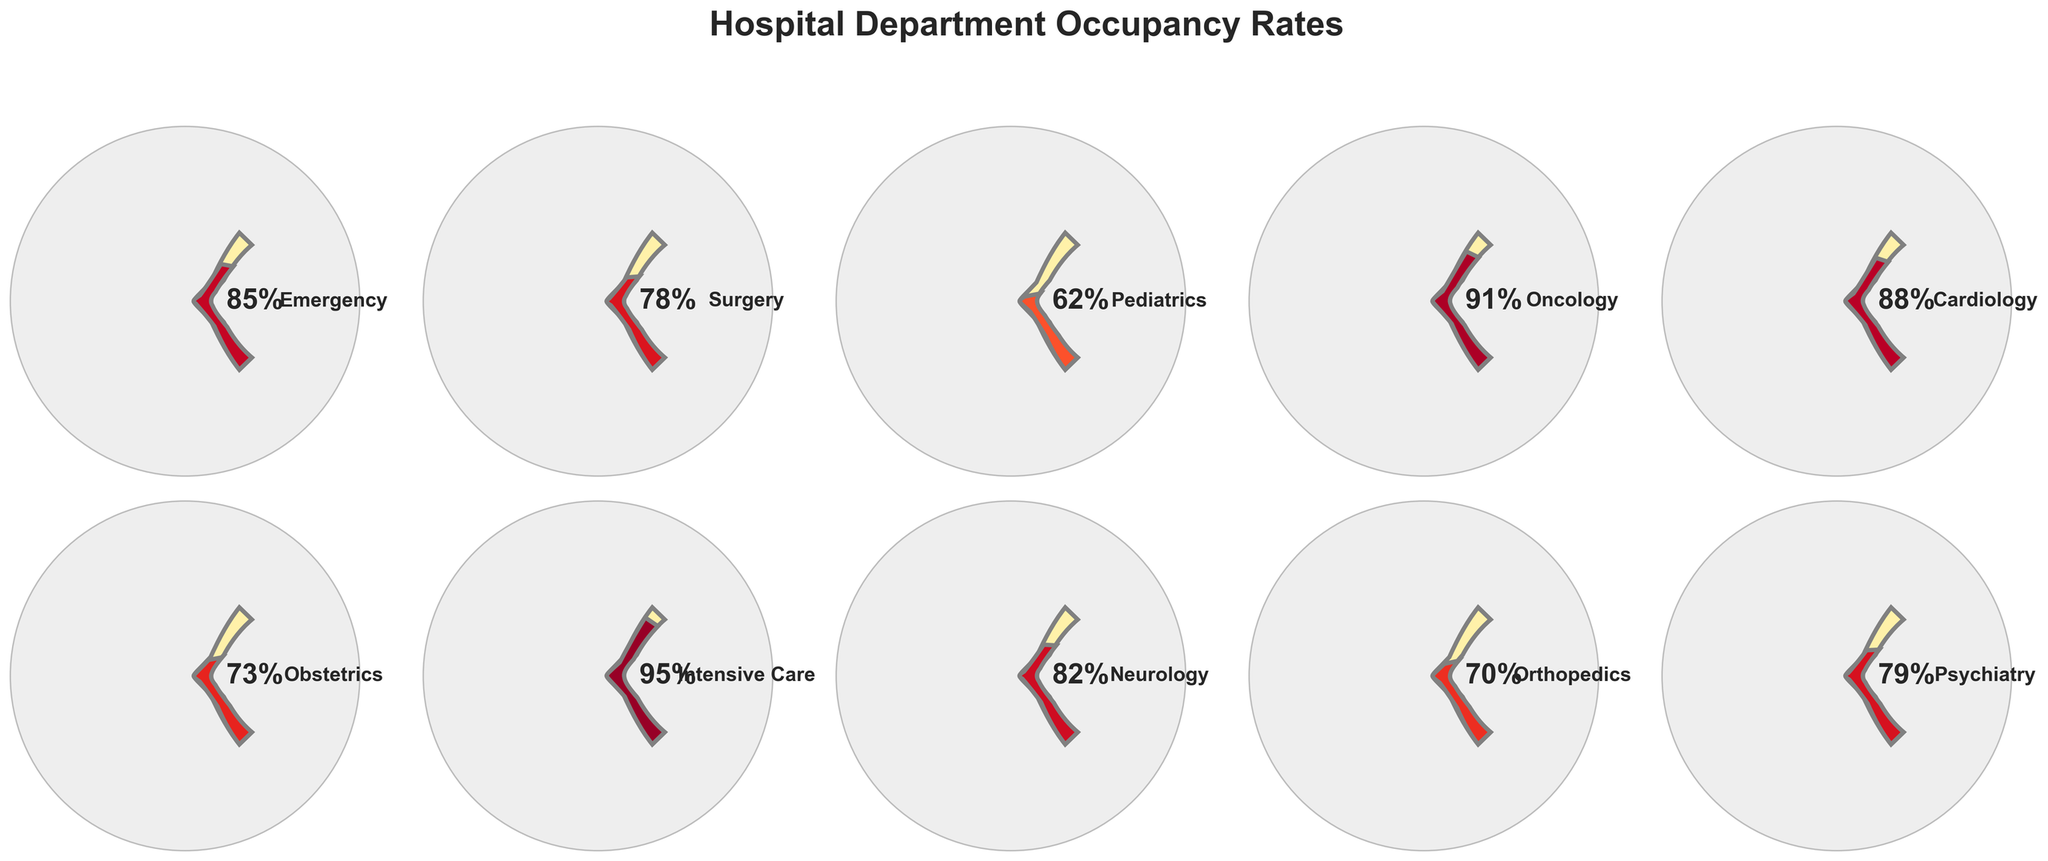What is the occupancy rate for the Intensive Care department? The Intensive Care department has an occupancy rate displayed already on the gauge chart.
Answer: 95% Which department has the lowest occupancy rate? Scan through the gauge charts to identify the smallest value. Pediatrics has the lowest rate.
Answer: Pediatrics Which departments have occupancy rates above 80%? Look for gauge charts that have values above 80%. They are Emergency, Oncology, Cardiology, Intensive Care, and Neurology.
Answer: Emergency, Oncology, Cardiology, Intensive Care, Neurology What is the overall average occupancy rate across all departments? Sum all the rates and divide by the number of departments: (85 + 78 + 62 + 91 + 88 + 73 + 95 + 82 + 70 + 79) / 10 = 80.3
Answer: 80.3% Compare the occupancy rates of Emergency and Cardiology departments. Which one is higher? The Emergency rate is 85%, and Cardiology is 88%. Hence, Cardiology is higher.
Answer: Cardiology What is the difference in occupancy rates between Surgery and Oncology departments? Subtract the occupancy rate of Surgery from Oncology. 91% - 78% = 13%
Answer: 13% Which department has a higher occupancy rate, Orthopedics or Obstetrics? Compare the values, Orthopedics has 70% and Obstetrics has 73%. So, Obstetrics is higher.
Answer: Obstetrics What is the median occupancy rate of the departments? List all rates in ascending order: 62, 70, 73, 78, 79, 82, 85, 88, 91, 95. The median is the average of the 5th and 6th values: (79 + 82) / 2 = 80.5
Answer: 80.5% Do more than half of the departments have an occupancy rate of over 75%? Count departments with rates above 75: Emergency, Surgery, Oncology, Cardiology, Intensive Care, Neurology, and Psychiatry (7 out of 10). This is more than half.
Answer: Yes How does the occupancy rate of Neurology compare to the average occupancy rate? Average rate is 80.3%. Neurology's rate is 82%, which is higher than the average.
Answer: Higher 